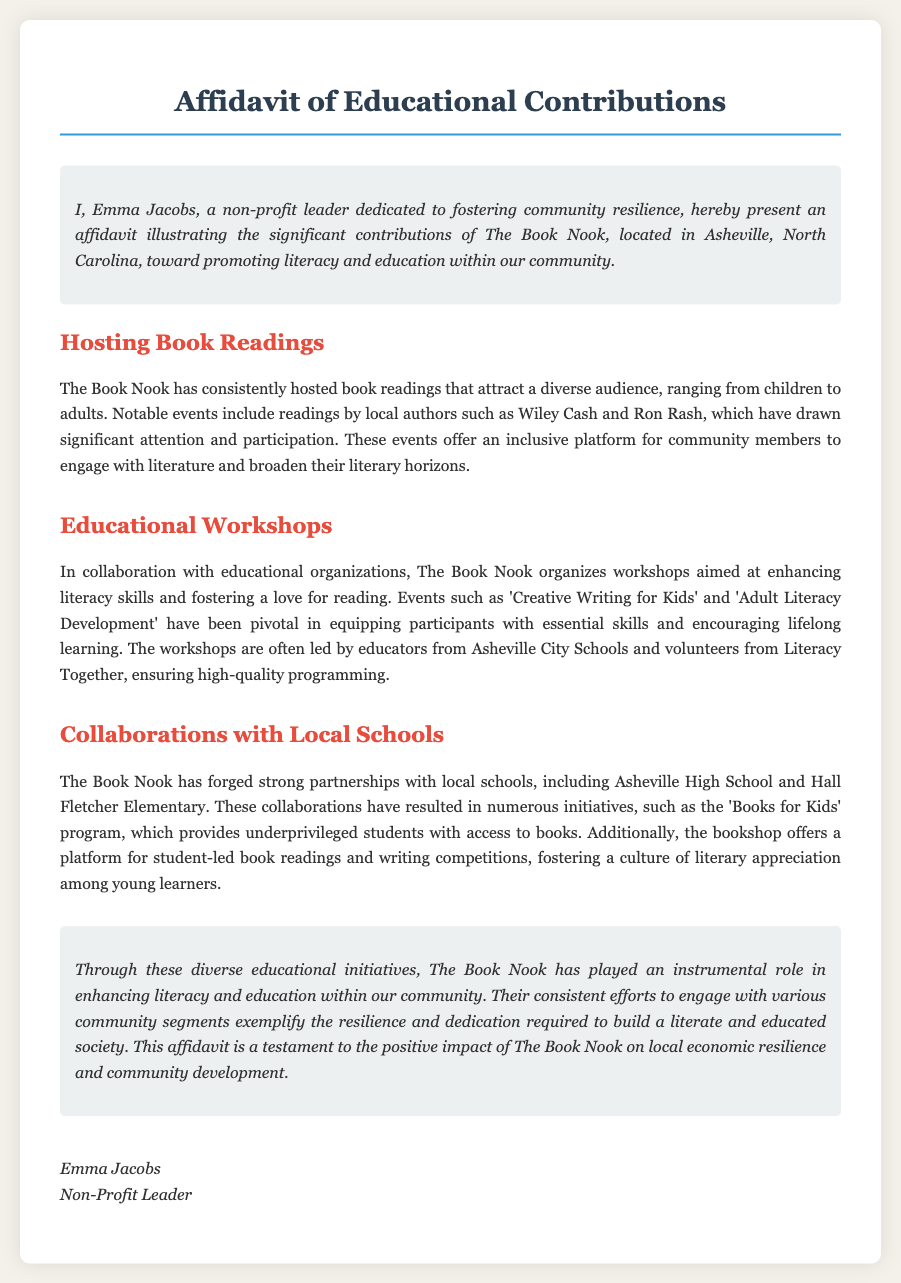What is the name of the non-profit leader presenting the affidavit? The name of the non-profit leader presenting the affidavit is Emma Jacobs.
Answer: Emma Jacobs What is the location of The Book Nook? The location of The Book Nook is stated as Asheville, North Carolina.
Answer: Asheville, North Carolina What type of events does The Book Nook host to attract a diverse audience? The Book Nook hosts book readings that attract a diverse audience.
Answer: Book readings Which two local authors are mentioned in the document? The two local authors mentioned are Wiley Cash and Ron Rash.
Answer: Wiley Cash and Ron Rash What is the name of the program that provides underprivileged students with access to books? The name of the program that provides underprivileged students with access to books is the 'Books for Kids' program.
Answer: Books for Kids Who leads the workshops organized by The Book Nook? The workshops are often led by educators from Asheville City Schools and volunteers from Literacy Together.
Answer: Educators from Asheville City Schools and volunteers from Literacy Together What is the main purpose of The Book Nook's educational initiatives? The main purpose of The Book Nook's educational initiatives is to enhance literacy and education within the community.
Answer: Enhance literacy and education What is the document type of this text? The document type is an affidavit.
Answer: Affidavit What is the tone of the introductory section? The tone of the introductory section is dedicated and positive regarding contributions to the community.
Answer: Dedicated and positive 